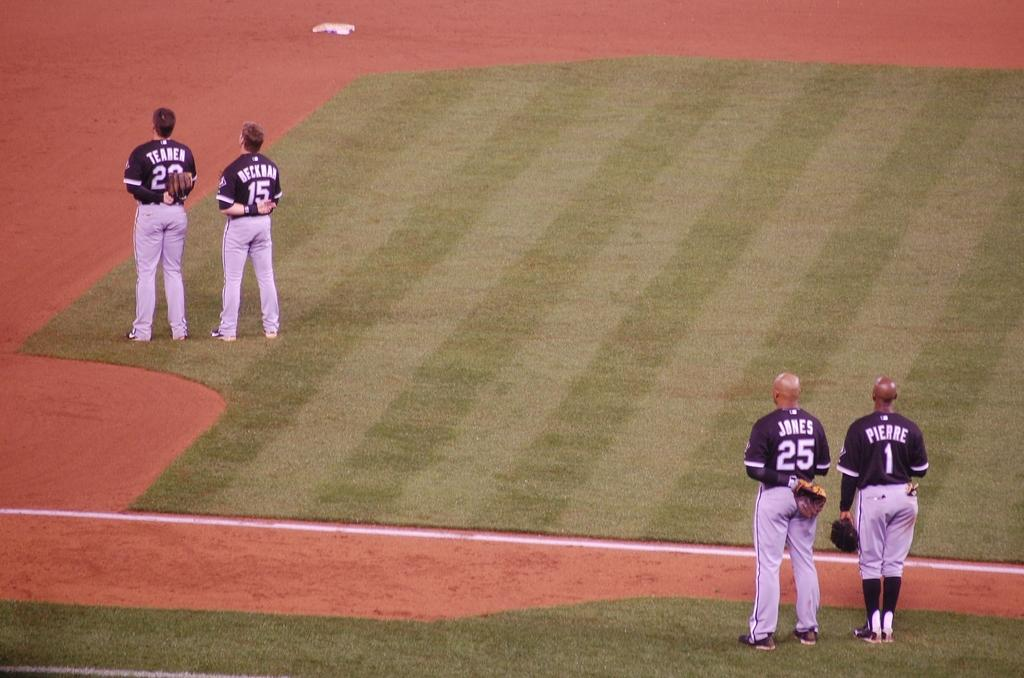What is the main subject of the picture? The main subject of the picture is a playground. What is the color of the mat in the playground? The playground has a green color mat. How many players are visible in the image? There are four players in the image. What are the players wearing? The players are wearing sports wear. How are the players positioned in the image? Two players are standing in the front, and two are standing at the back. What type of books are the players reading during their vacation in the image? There is no mention of books or vacation in the image; it features a playground with four players wearing sports wear. 